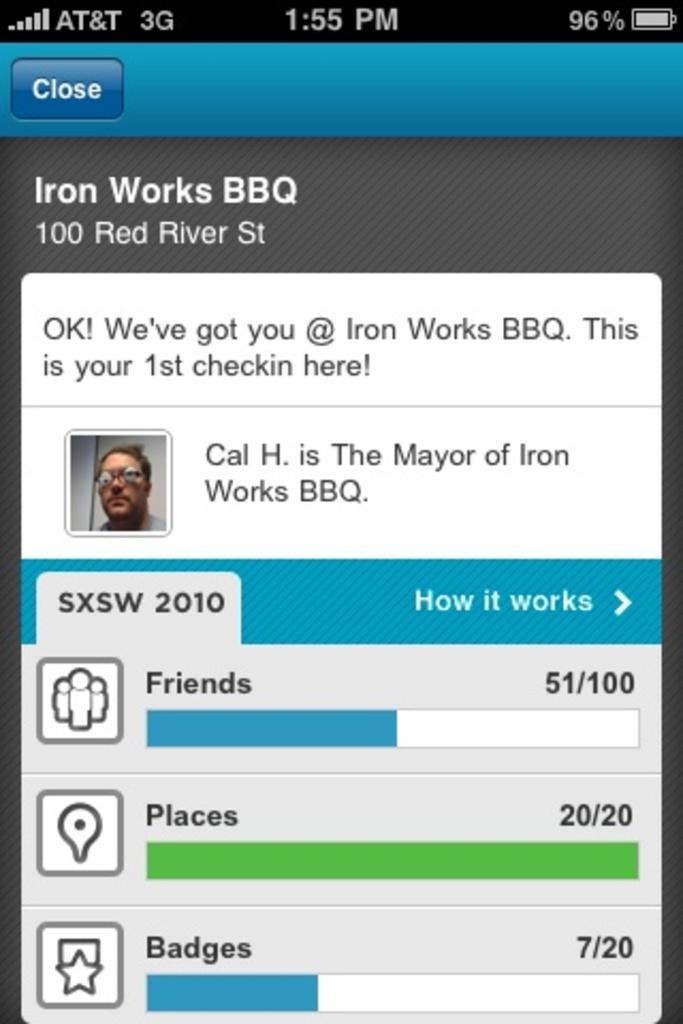How would you summarize this image in a sentence or two? In this picture we can see a screen and on this screen we can see a person, symbols and some text. 